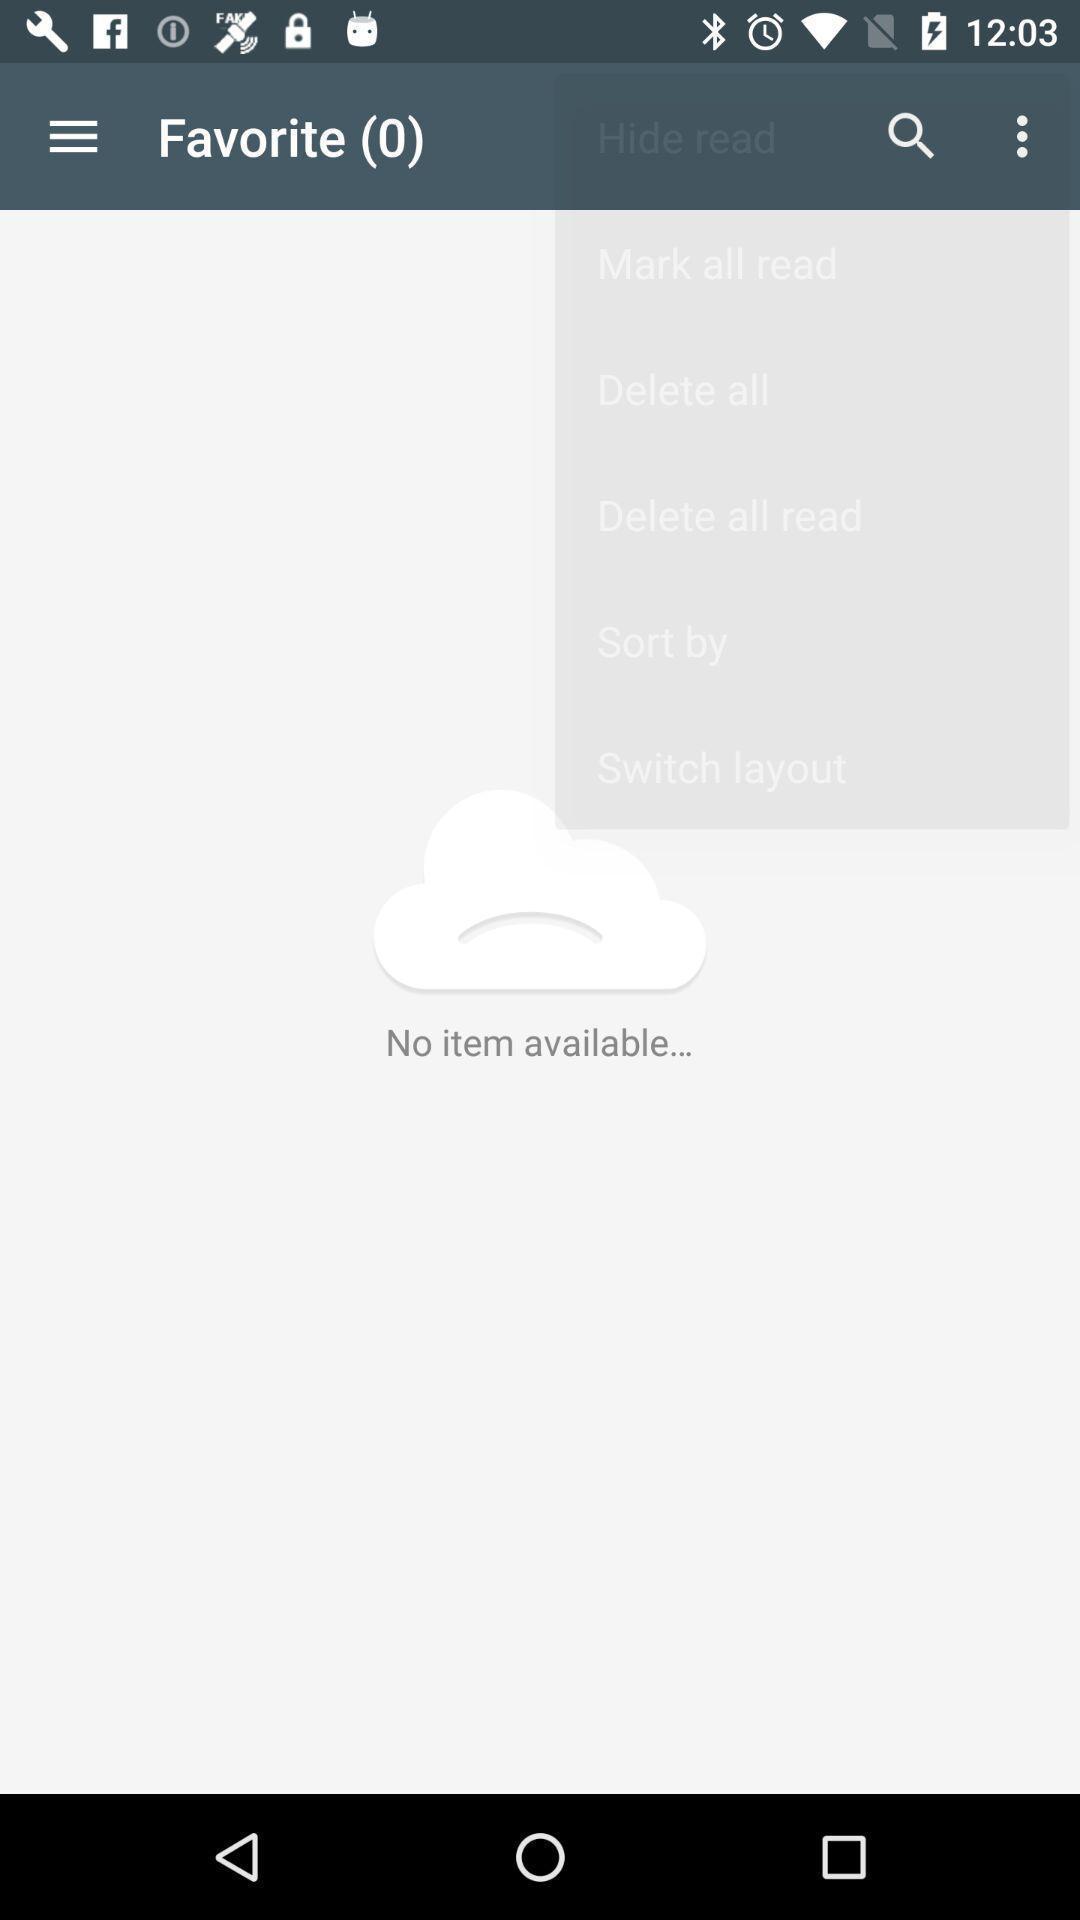Describe the key features of this screenshot. Page displaying favorite. 